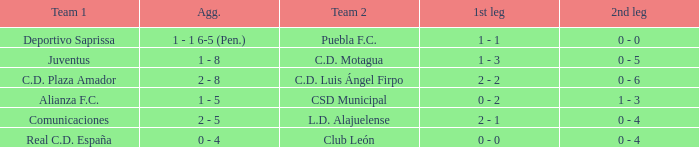What is the 1st leg where Team 1 is C.D. Plaza Amador? 2 - 2. 